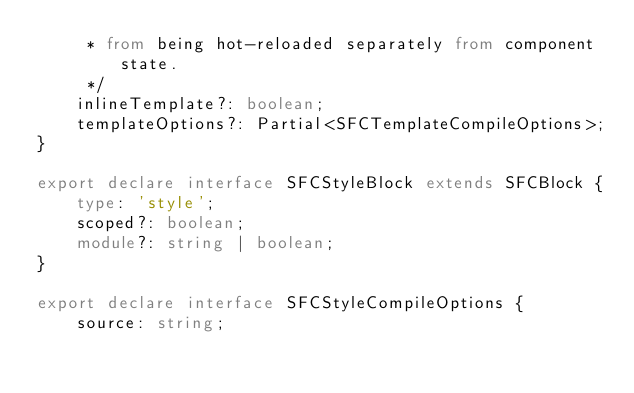<code> <loc_0><loc_0><loc_500><loc_500><_TypeScript_>     * from being hot-reloaded separately from component state.
     */
    inlineTemplate?: boolean;
    templateOptions?: Partial<SFCTemplateCompileOptions>;
}

export declare interface SFCStyleBlock extends SFCBlock {
    type: 'style';
    scoped?: boolean;
    module?: string | boolean;
}

export declare interface SFCStyleCompileOptions {
    source: string;</code> 